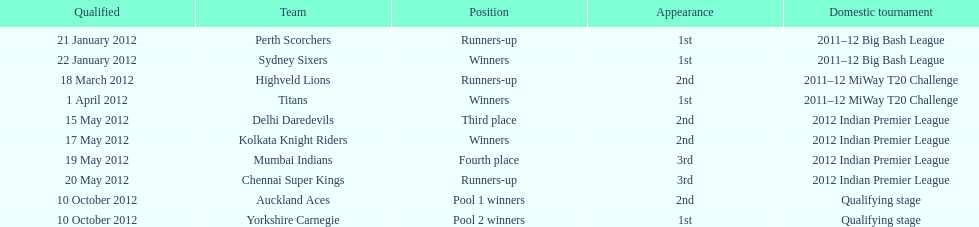Which team came in after the titans in the miway t20 challenge? Highveld Lions. 